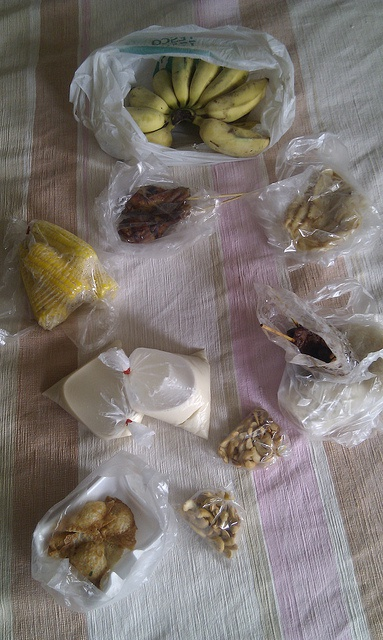Describe the objects in this image and their specific colors. I can see a banana in gray, olive, and black tones in this image. 